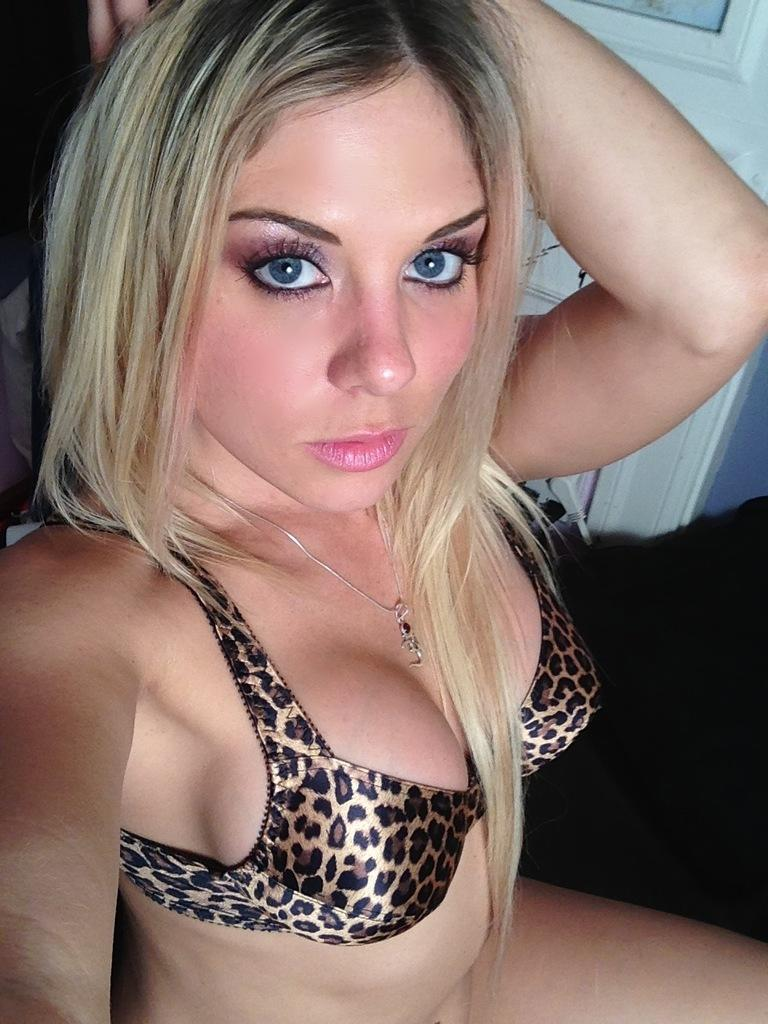What is the hair color of the woman in the image? The woman in the image has blond hair. What type of clothing is the woman wearing? The woman is wearing a bikini. Can you describe any architectural features in the image? Yes, there is a door visible in the image. What is the name of the woman's sister in the image? There is no information about a sister in the image, nor is there any information about the woman's name. 